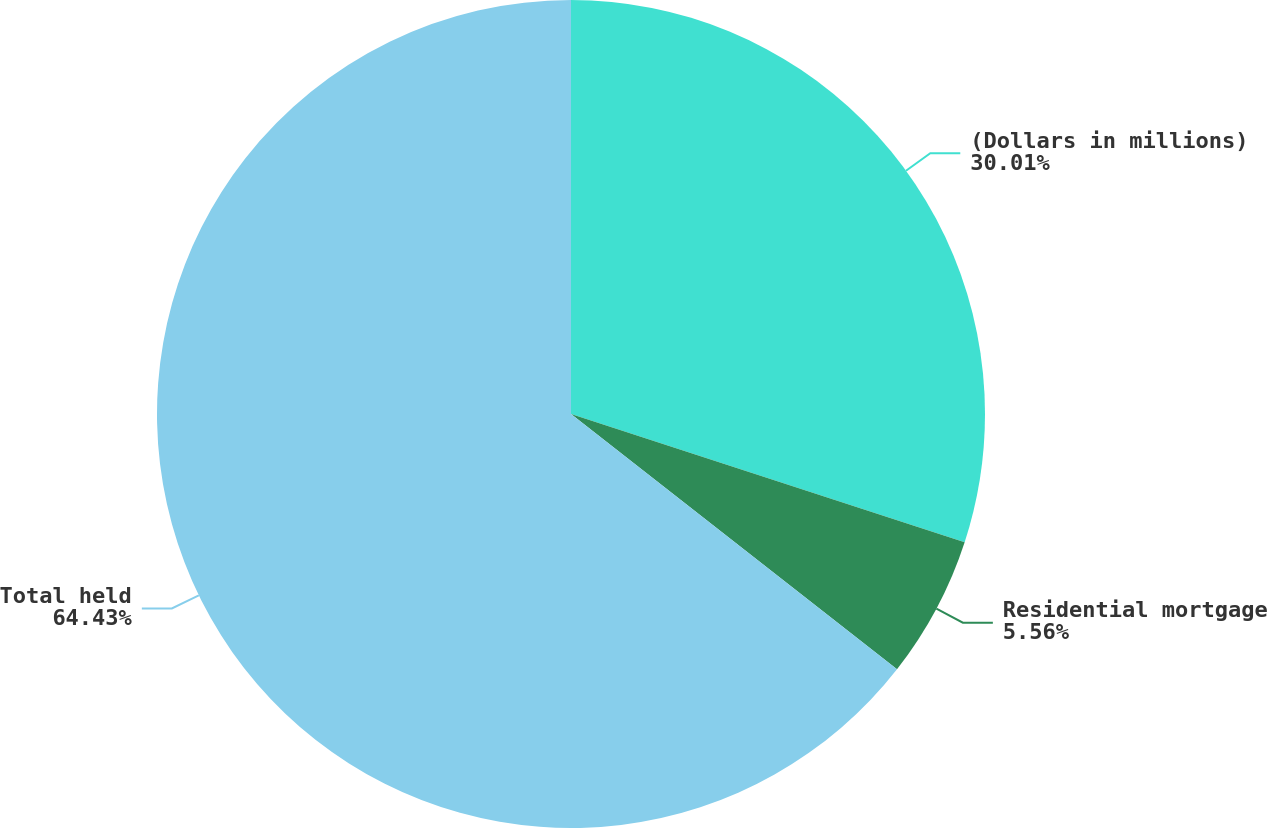Convert chart. <chart><loc_0><loc_0><loc_500><loc_500><pie_chart><fcel>(Dollars in millions)<fcel>Residential mortgage<fcel>Total held<nl><fcel>30.01%<fcel>5.56%<fcel>64.43%<nl></chart> 